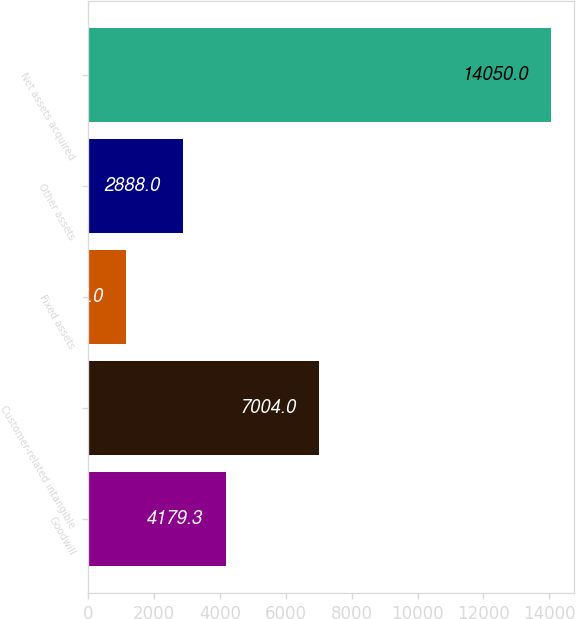Convert chart. <chart><loc_0><loc_0><loc_500><loc_500><bar_chart><fcel>Goodwill<fcel>Customer-related intangible<fcel>Fixed assets<fcel>Other assets<fcel>Net assets acquired<nl><fcel>4179.3<fcel>7004<fcel>1137<fcel>2888<fcel>14050<nl></chart> 